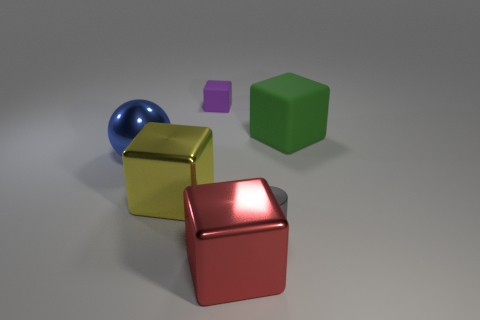Do the large green thing and the sphere have the same material?
Your answer should be very brief. No. There is a rubber thing that is to the right of the small gray shiny cylinder; are there any gray cylinders that are right of it?
Provide a succinct answer. No. Are there any other small shiny objects of the same shape as the yellow object?
Make the answer very short. No. Do the tiny cube and the sphere have the same color?
Provide a short and direct response. No. There is a large block that is on the left side of the matte block that is behind the green rubber block; what is it made of?
Your answer should be compact. Metal. What is the size of the purple object?
Provide a short and direct response. Small. What is the size of the red block that is the same material as the small gray cylinder?
Your answer should be compact. Large. There is a metal cube on the right side of the yellow shiny block; does it have the same size as the purple matte cube?
Give a very brief answer. No. The large metallic thing that is right of the small object behind the rubber thing that is to the right of the tiny cylinder is what shape?
Make the answer very short. Cube. What number of objects are yellow things or large yellow things in front of the tiny matte block?
Offer a very short reply. 1. 